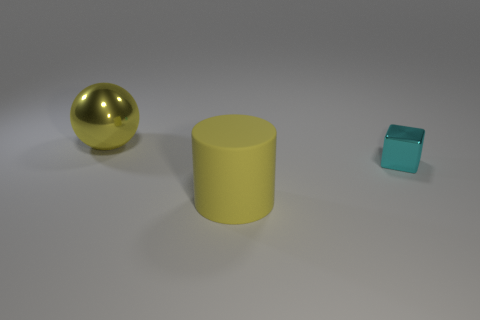Is there any other thing that is made of the same material as the large cylinder?
Keep it short and to the point. No. Is the shape of the large yellow shiny object the same as the big object that is in front of the tiny cyan cube?
Offer a terse response. No. There is a object that is the same color as the big cylinder; what material is it?
Offer a very short reply. Metal. What is the material of the other thing that is the same size as the yellow matte thing?
Ensure brevity in your answer.  Metal. Are there any large matte cylinders of the same color as the large ball?
Your response must be concise. Yes. There is a object that is both to the left of the cyan object and in front of the big yellow metal thing; what is its shape?
Offer a terse response. Cylinder. What number of large yellow balls are made of the same material as the tiny object?
Your answer should be compact. 1. Are there fewer cylinders that are right of the big yellow matte object than yellow shiny objects that are to the right of the big metal ball?
Your answer should be compact. No. There is a big object to the left of the big thing in front of the metallic ball behind the yellow matte cylinder; what is it made of?
Your response must be concise. Metal. How big is the thing that is on the left side of the cyan block and behind the yellow rubber cylinder?
Offer a very short reply. Large. 